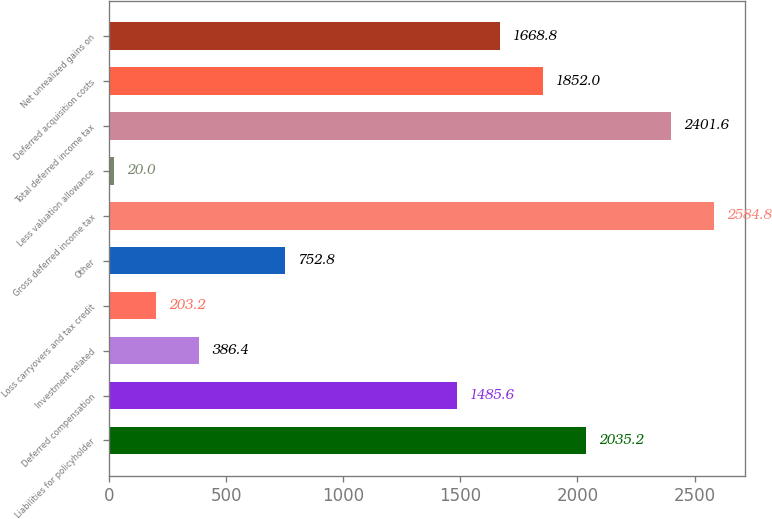<chart> <loc_0><loc_0><loc_500><loc_500><bar_chart><fcel>Liabilities for policyholder<fcel>Deferred compensation<fcel>Investment related<fcel>Loss carryovers and tax credit<fcel>Other<fcel>Gross deferred income tax<fcel>Less valuation allowance<fcel>Total deferred income tax<fcel>Deferred acquisition costs<fcel>Net unrealized gains on<nl><fcel>2035.2<fcel>1485.6<fcel>386.4<fcel>203.2<fcel>752.8<fcel>2584.8<fcel>20<fcel>2401.6<fcel>1852<fcel>1668.8<nl></chart> 